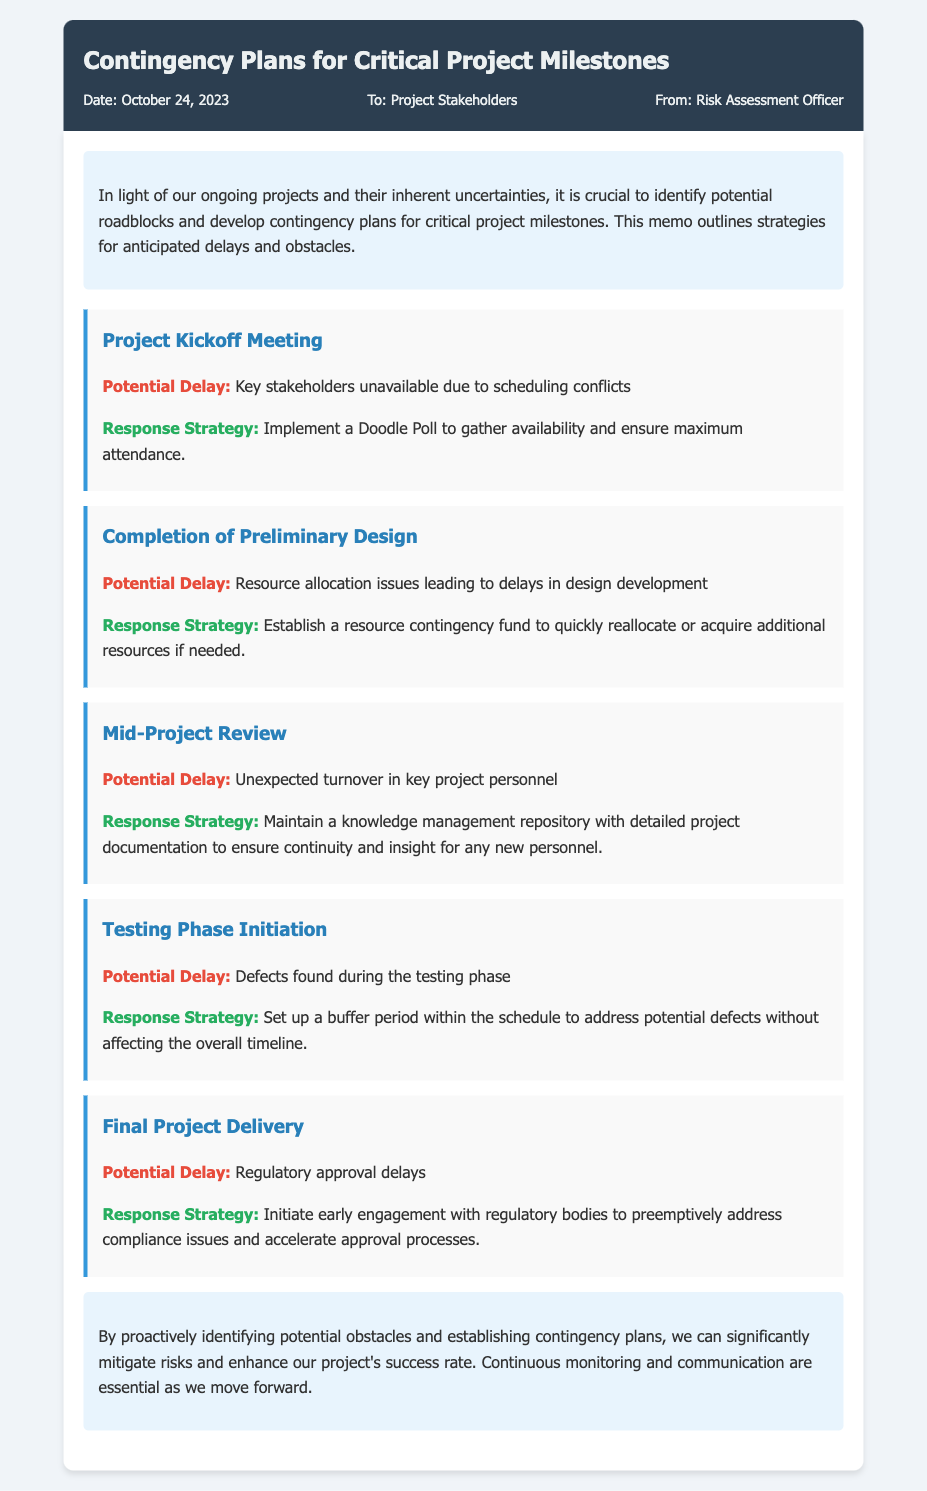What is the date of the memo? The date of the memo is stated in the memo details section, which is October 24, 2023.
Answer: October 24, 2023 Who is the memo addressed to? The memo details section specifies that the memo is addressed to Project Stakeholders.
Answer: Project Stakeholders What is the first potential delay listed? The first potential delay is outlined in the contingency plan for the Project Kickoff Meeting, stating key stakeholders are unavailable due to scheduling conflicts.
Answer: Key stakeholders unavailable due to scheduling conflicts What contingency strategy is suggested for the testing phase? The response strategy for the Testing Phase Initiation outlines setting up a buffer period to address potential defects.
Answer: Set up a buffer period How many critical project milestones are mentioned? The memo contains five contingency plans, corresponding to critical milestones in the project.
Answer: Five What is the response strategy for resource allocation issues? The response strategy for these issues is to establish a resource contingency fund to quickly reallocate or acquire additional resources if needed.
Answer: Establish a resource contingency fund What is mentioned as a key aspect for ensuring continuity during unexpected turnover? The memo suggests maintaining a knowledge management repository with detailed project documentation for continuity.
Answer: Knowledge management repository What type of document is this? This document is a memo outlining contingency plans for project milestones.
Answer: Memo What should be continuously monitored as projects move forward? The conclusion emphasizes the need for continuous monitoring and communication as essential components for moving forward in projects.
Answer: Continuous monitoring and communication 